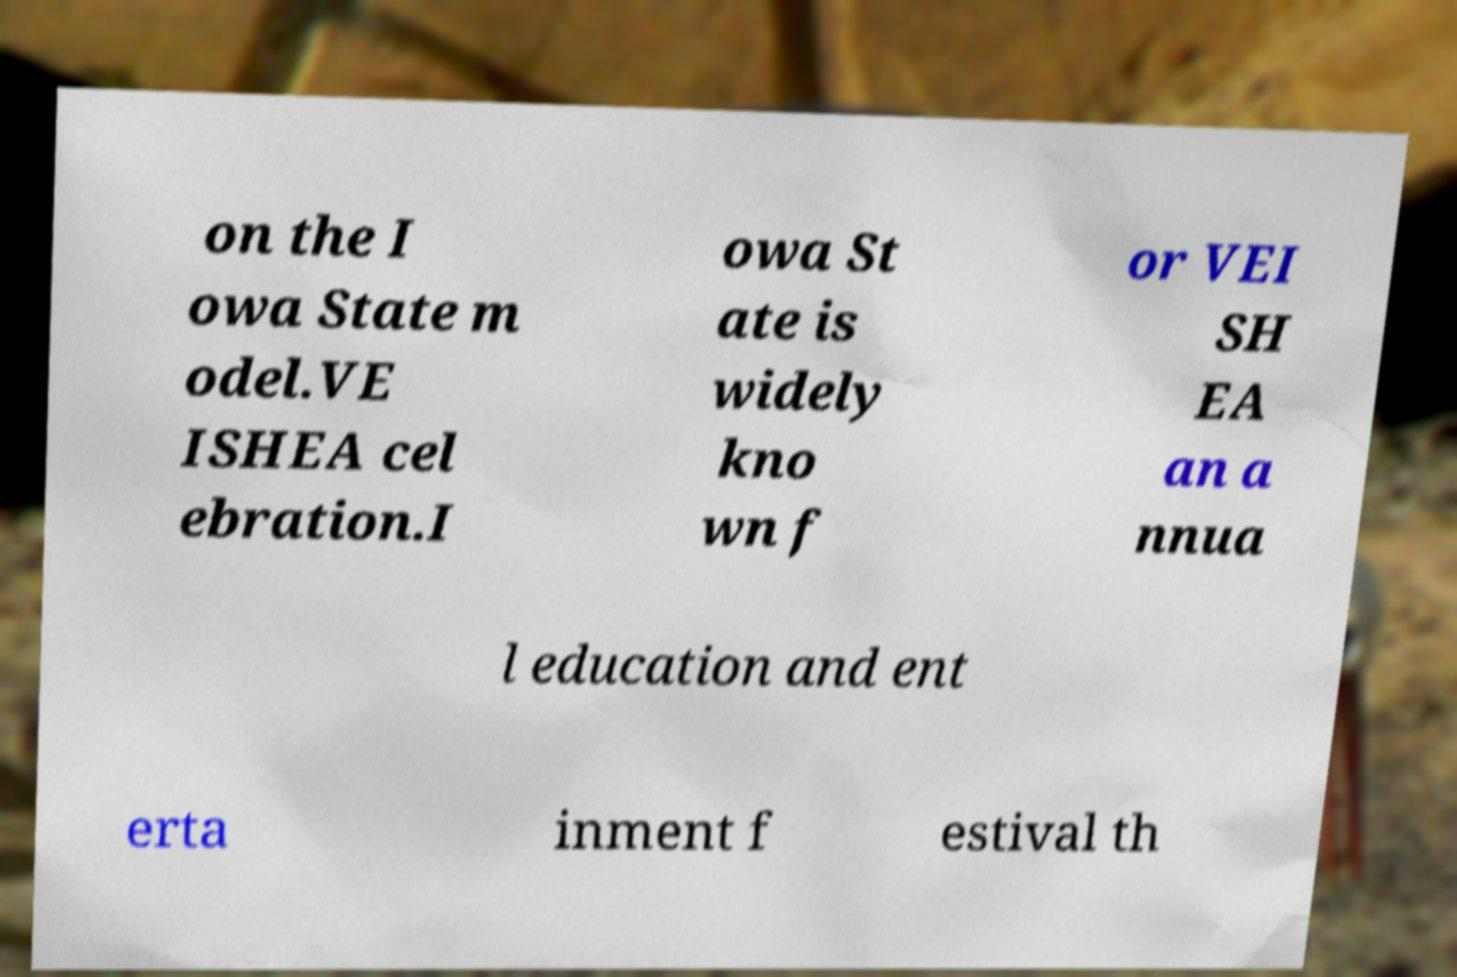For documentation purposes, I need the text within this image transcribed. Could you provide that? on the I owa State m odel.VE ISHEA cel ebration.I owa St ate is widely kno wn f or VEI SH EA an a nnua l education and ent erta inment f estival th 